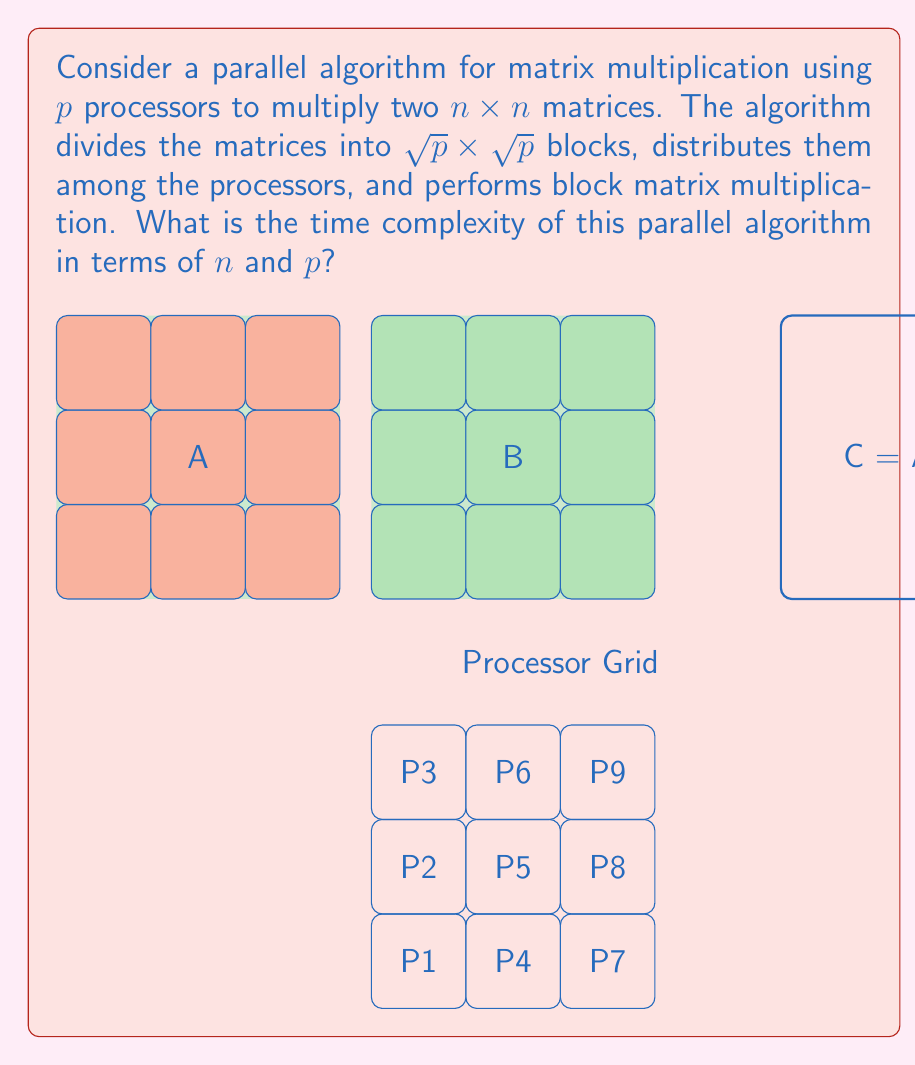Could you help me with this problem? Let's analyze the time complexity step by step:

1) First, we need to understand how the matrices are divided. With $p$ processors, we divide each $n \times n$ matrix into $\sqrt{p} \times \sqrt{p}$ blocks, each of size $\frac{n}{\sqrt{p}} \times \frac{n}{\sqrt{p}}$.

2) Each processor is responsible for computing one block of the result matrix C. To do this, it needs to multiply a row of blocks from matrix A with a column of blocks from matrix B.

3) The number of block multiplications each processor needs to perform is $\sqrt{p}$, as there are $\sqrt{p}$ blocks in each row/column.

4) For each block multiplication, the processor needs to multiply two $\frac{n}{\sqrt{p}} \times \frac{n}{\sqrt{p}}$ matrices. The time complexity of multiplying two matrices of size $m \times m$ is $O(m^3)$. Here, $m = \frac{n}{\sqrt{p}}$.

5) Therefore, the time for each block multiplication is:

   $$O\left(\left(\frac{n}{\sqrt{p}}\right)^3\right) = O\left(\frac{n^3}{p^{3/2}}\right)$$

6) Each processor performs $\sqrt{p}$ such block multiplications, so the total time for each processor is:

   $$O\left(\sqrt{p} \cdot \frac{n^3}{p^{3/2}}\right) = O\left(\frac{n^3}{p}\right)$$

7) All processors work in parallel, so the overall time complexity of the algorithm is the same as the time complexity for each processor.

8) We also need to consider the time for distributing the initial data and collecting the results, which is $O(n^2)$. However, for large $n$, this term is dominated by the computation time.

Therefore, the overall time complexity of this parallel matrix multiplication algorithm is $O\left(\frac{n^3}{p}\right)$.
Answer: $O\left(\frac{n^3}{p}\right)$ 